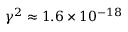<formula> <loc_0><loc_0><loc_500><loc_500>\gamma ^ { 2 } \approx 1 . 6 \times 1 0 ^ { - 1 8 }</formula> 